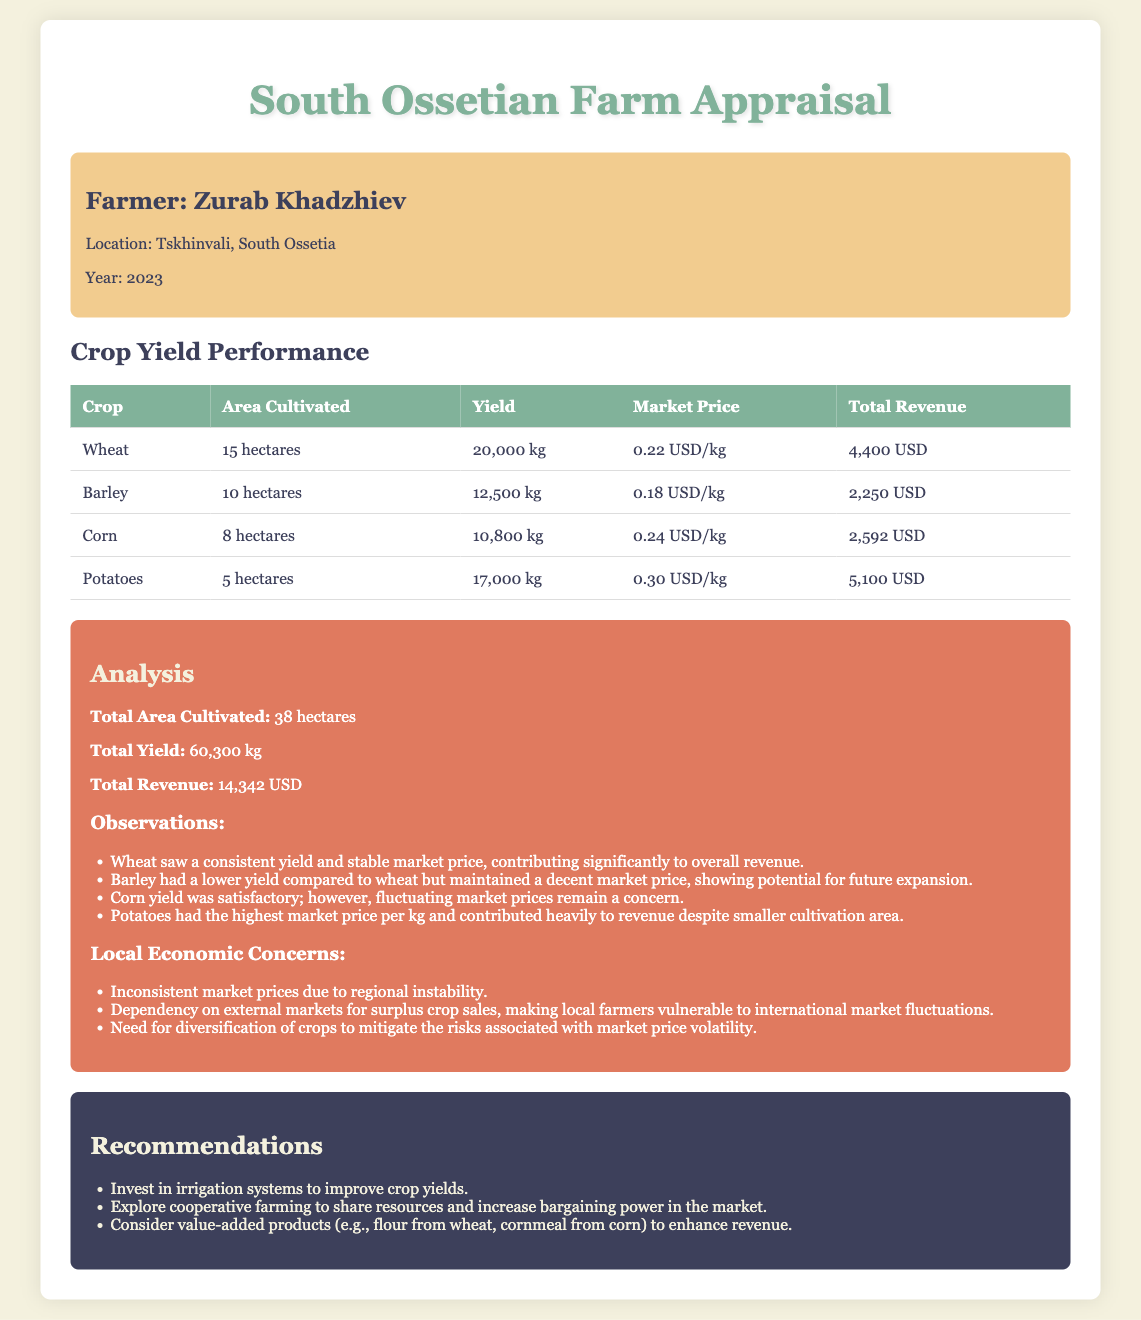What is the total yield? The total yield is the sum of yields from all crops listed in the document, which is 20000 kg (Wheat) + 12500 kg (Barley) + 10800 kg (Corn) + 17000 kg (Potatoes) = 60300 kg.
Answer: 60300 kg What is the market price of potatoes? The market price for potatoes, as stated in the document, is $0.30 per kg.
Answer: 0.30 USD/kg How many hectares are dedicated to wheat cultivation? The document specifies that wheat is cultivated on 15 hectares.
Answer: 15 hectares What is the total revenue from corn? The total revenue from corn is listed as $2592 in the document, which is calculated by multiplying yield (10800 kg) with market price (0.24 USD/kg).
Answer: 2592 USD What is one concern mentioned about local economics? The analysis section notes a concern regarding inconsistent market prices due to regional instability, highlighting the vulnerability of local farmers.
Answer: Inconsistent market prices What is the area cultivated for barley? The area cultivated for barley is stated as 10 hectares.
Answer: 10 hectares Which crop had the highest market price? Among the crops listed, potatoes had the highest market price of $0.30 per kg.
Answer: Potatoes What recommendation is made for improving crop yields? The recommendations section suggests investing in irrigation systems to enhance crop yields.
Answer: Invest in irrigation systems What is the total area cultivated? The total area cultivated is the sum of all areas from each crop, which amounts to 38 hectares as stated in the document.
Answer: 38 hectares What was the yield of barley? The yield for barley is mentioned as 12500 kg in the document.
Answer: 12500 kg 